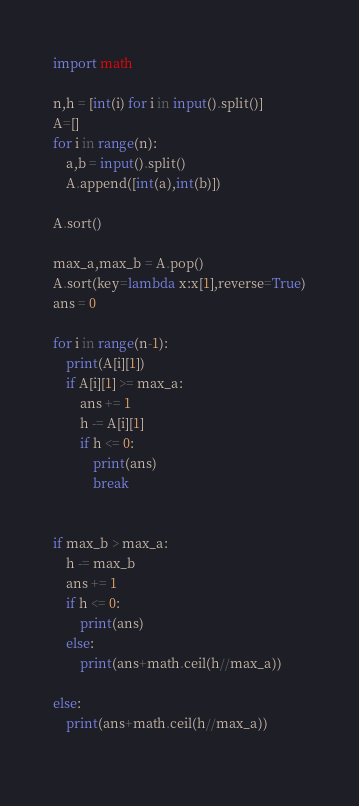Convert code to text. <code><loc_0><loc_0><loc_500><loc_500><_Python_>import math

n,h = [int(i) for i in input().split()]
A=[]
for i in range(n):
    a,b = input().split()
    A.append([int(a),int(b)])
    
A.sort()

max_a,max_b = A.pop()
A.sort(key=lambda x:x[1],reverse=True)
ans = 0

for i in range(n-1):
    print(A[i][1])
    if A[i][1] >= max_a:
        ans += 1
        h -= A[i][1]
        if h <= 0:
            print(ans)
            break

    
if max_b > max_a:
    h -= max_b
    ans += 1
    if h <= 0:
        print(ans)
    else:
        print(ans+math.ceil(h//max_a))
        
else:
    print(ans+math.ceil(h//max_a))
    </code> 